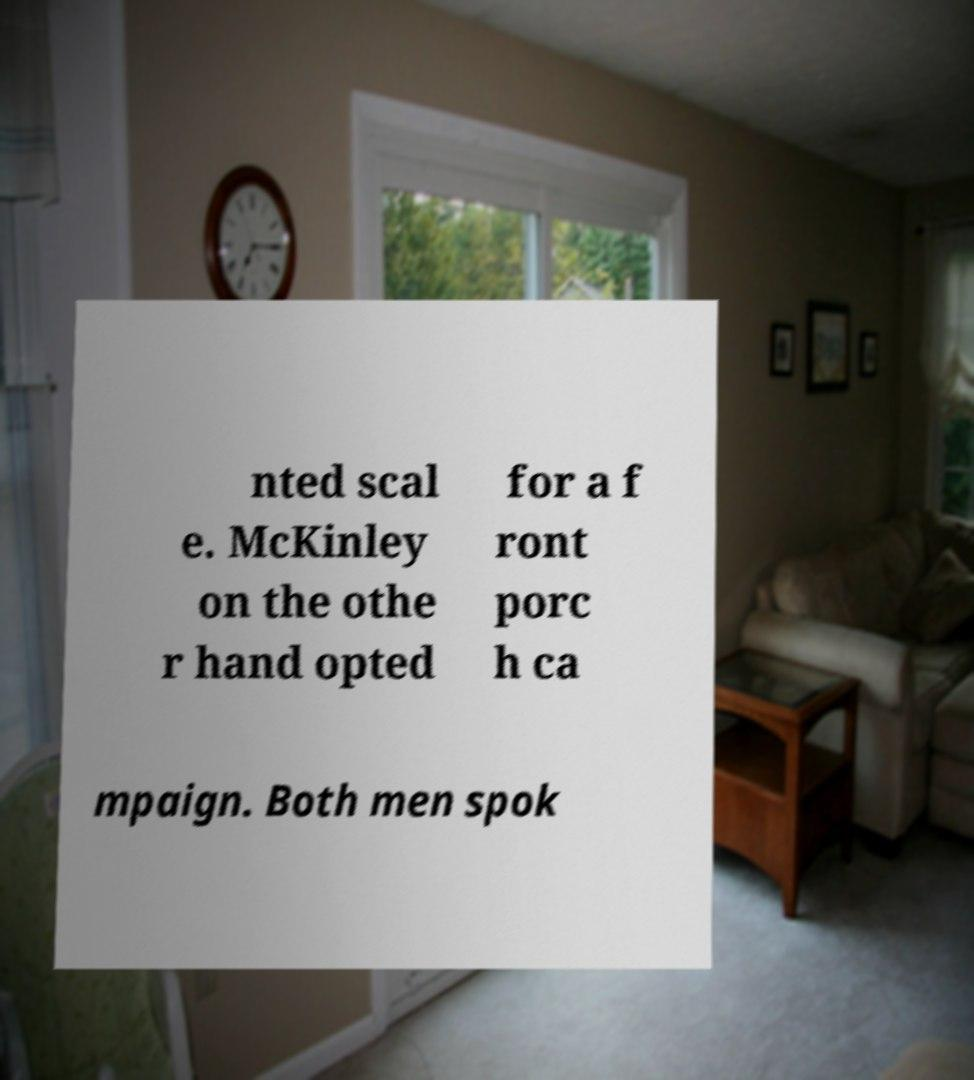Could you assist in decoding the text presented in this image and type it out clearly? nted scal e. McKinley on the othe r hand opted for a f ront porc h ca mpaign. Both men spok 